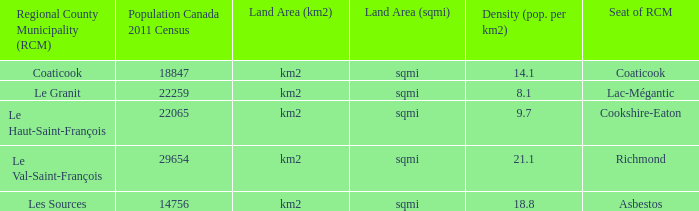7? Cookshire-Eaton. 